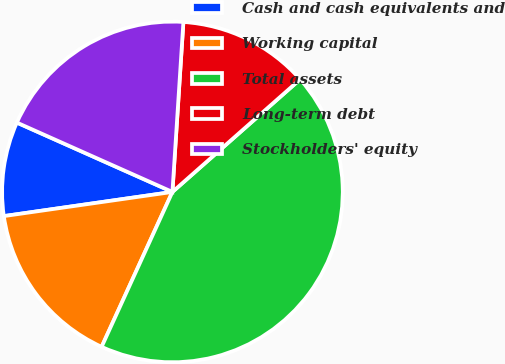Convert chart to OTSL. <chart><loc_0><loc_0><loc_500><loc_500><pie_chart><fcel>Cash and cash equivalents and<fcel>Working capital<fcel>Total assets<fcel>Long-term debt<fcel>Stockholders' equity<nl><fcel>8.94%<fcel>15.91%<fcel>43.32%<fcel>12.47%<fcel>19.35%<nl></chart> 